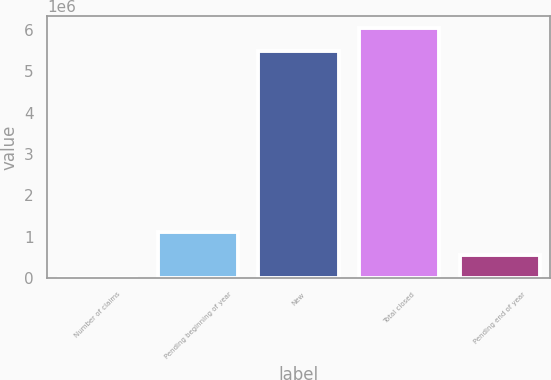<chart> <loc_0><loc_0><loc_500><loc_500><bar_chart><fcel>Number of claims<fcel>Pending beginning of year<fcel>New<fcel>Total closed<fcel>Pending end of year<nl><fcel>2009<fcel>1.10339e+06<fcel>5.48294e+06<fcel>6.03363e+06<fcel>552699<nl></chart> 